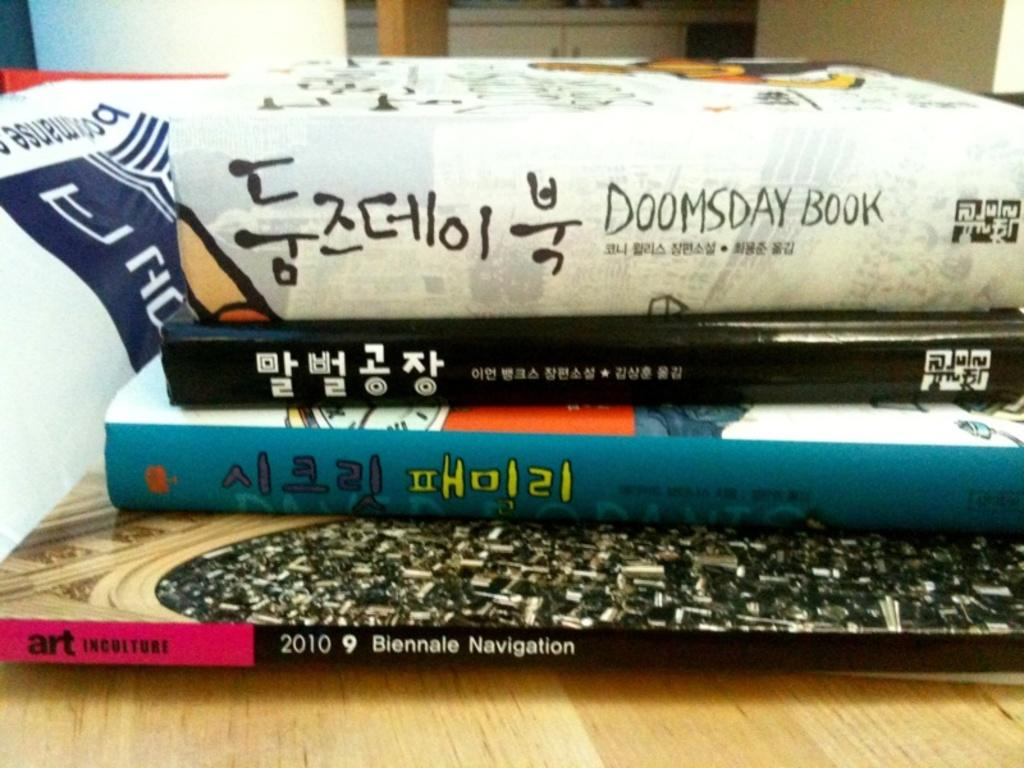<image>
Summarize the visual content of the image. Four books stacked on top of one another with a book named "Doomsday Book" on top. 